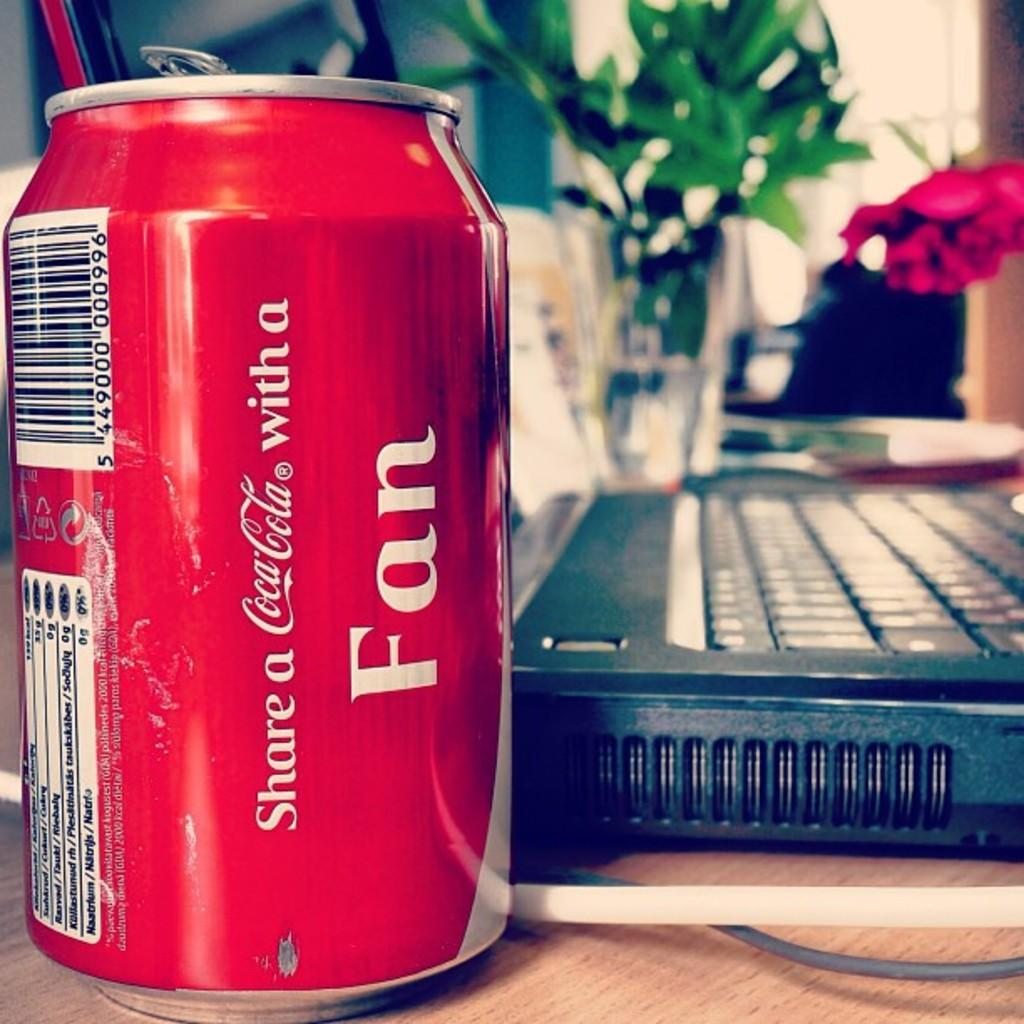<image>
Create a compact narrative representing the image presented. Coca cola can that is next to a laptop computer 